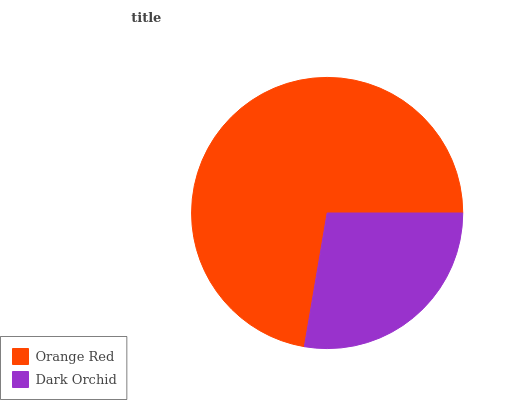Is Dark Orchid the minimum?
Answer yes or no. Yes. Is Orange Red the maximum?
Answer yes or no. Yes. Is Dark Orchid the maximum?
Answer yes or no. No. Is Orange Red greater than Dark Orchid?
Answer yes or no. Yes. Is Dark Orchid less than Orange Red?
Answer yes or no. Yes. Is Dark Orchid greater than Orange Red?
Answer yes or no. No. Is Orange Red less than Dark Orchid?
Answer yes or no. No. Is Orange Red the high median?
Answer yes or no. Yes. Is Dark Orchid the low median?
Answer yes or no. Yes. Is Dark Orchid the high median?
Answer yes or no. No. Is Orange Red the low median?
Answer yes or no. No. 